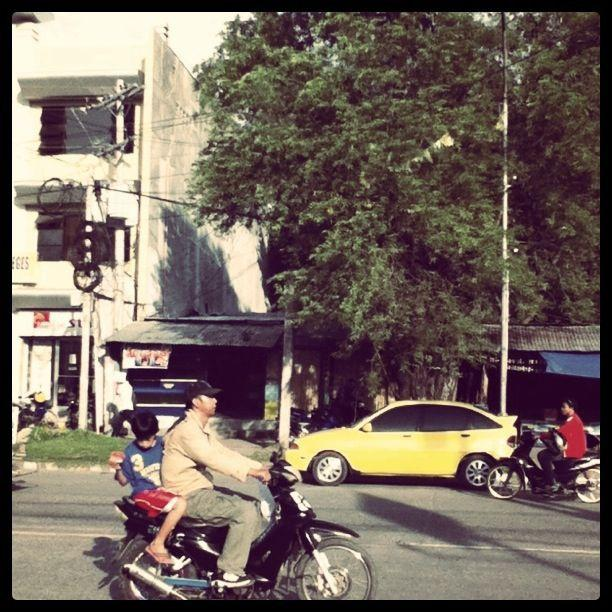Which mode of transportation shown here is most economical? Please explain your reasoning. motor cycle. A motorcycle is small and doesn't use much gas. 